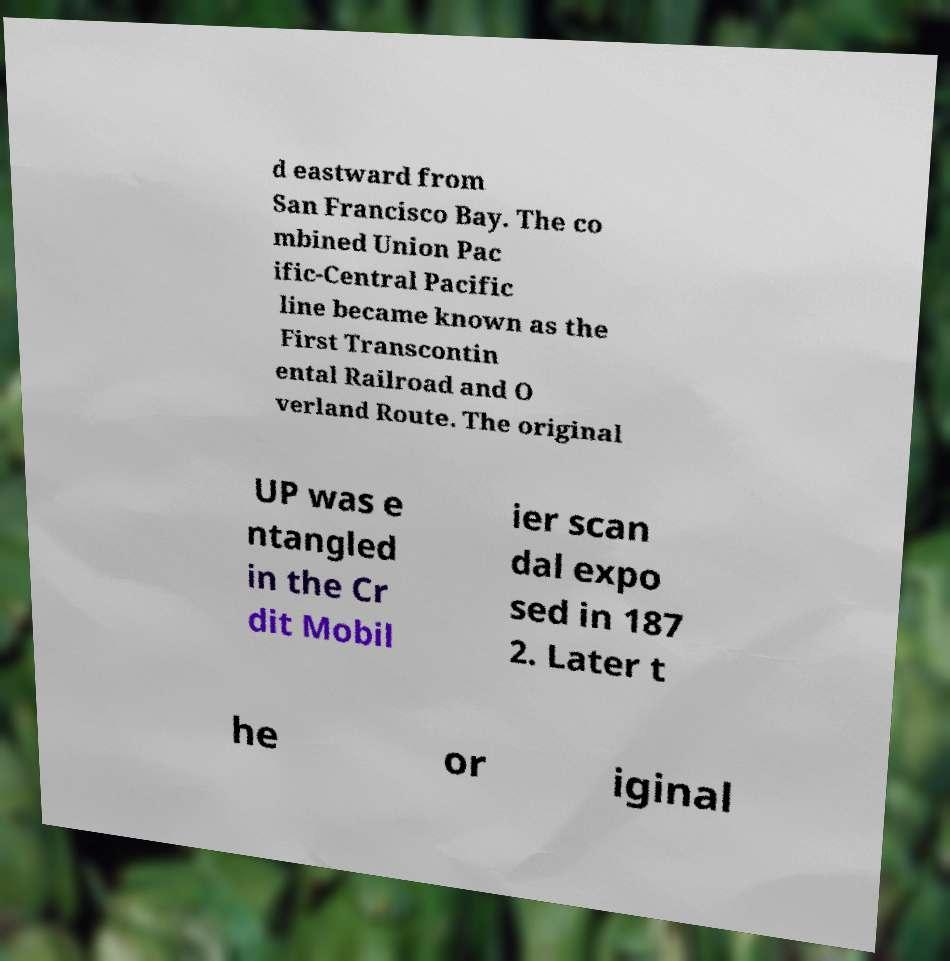There's text embedded in this image that I need extracted. Can you transcribe it verbatim? d eastward from San Francisco Bay. The co mbined Union Pac ific-Central Pacific line became known as the First Transcontin ental Railroad and O verland Route. The original UP was e ntangled in the Cr dit Mobil ier scan dal expo sed in 187 2. Later t he or iginal 